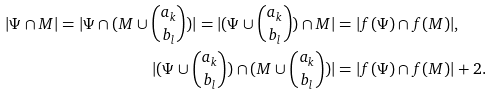<formula> <loc_0><loc_0><loc_500><loc_500>| \Psi \cap M | = | \Psi \cap ( M \cup \binom { a _ { k } } { b _ { l } } ) | = | ( \Psi \cup \binom { a _ { k } } { b _ { l } } ) \cap M | & = | f ( \Psi ) \cap f ( M ) | , \\ | ( \Psi \cup \binom { a _ { k } } { b _ { l } } ) \cap ( M \cup \binom { a _ { k } } { b _ { l } } ) | & = | f ( \Psi ) \cap f ( M ) | + 2 .</formula> 